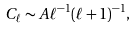Convert formula to latex. <formula><loc_0><loc_0><loc_500><loc_500>C _ { \ell } \sim A \ell ^ { - 1 } ( \ell + 1 ) ^ { - 1 } ,</formula> 